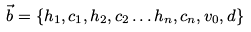Convert formula to latex. <formula><loc_0><loc_0><loc_500><loc_500>\vec { b } = \{ h _ { 1 } , c _ { 1 } , h _ { 2 } , c _ { 2 } \dots h _ { n } , c _ { n } , v _ { 0 } , d \}</formula> 